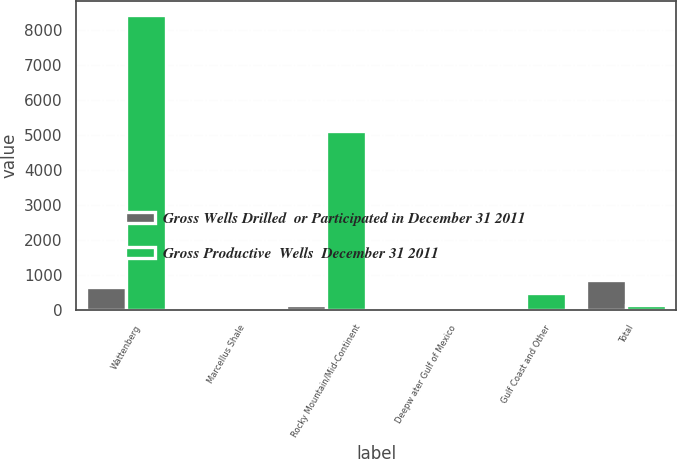Convert chart. <chart><loc_0><loc_0><loc_500><loc_500><stacked_bar_chart><ecel><fcel>Wattenberg<fcel>Marcellus Shale<fcel>Rocky Mountain/Mid-Continent<fcel>Deepw ater Gulf of Mexico<fcel>Gulf Coast and Other<fcel>Total<nl><fcel>Gross Wells Drilled  or Participated in December 31 2011<fcel>663<fcel>23<fcel>157<fcel>1<fcel>11<fcel>855<nl><fcel>Gross Productive  Wells  December 31 2011<fcel>8415<fcel>102<fcel>5120<fcel>7<fcel>490<fcel>157<nl></chart> 